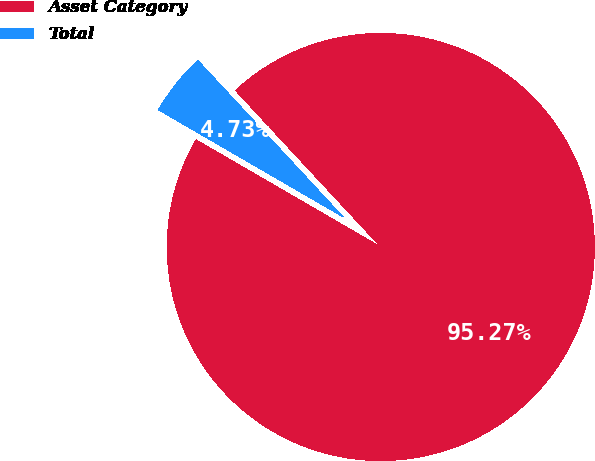<chart> <loc_0><loc_0><loc_500><loc_500><pie_chart><fcel>Asset Category<fcel>Total<nl><fcel>95.27%<fcel>4.73%<nl></chart> 